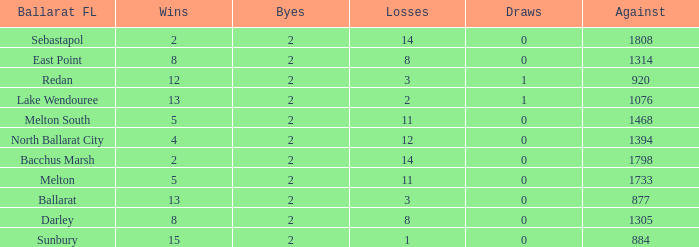Parse the table in full. {'header': ['Ballarat FL', 'Wins', 'Byes', 'Losses', 'Draws', 'Against'], 'rows': [['Sebastapol', '2', '2', '14', '0', '1808'], ['East Point', '8', '2', '8', '0', '1314'], ['Redan', '12', '2', '3', '1', '920'], ['Lake Wendouree', '13', '2', '2', '1', '1076'], ['Melton South', '5', '2', '11', '0', '1468'], ['North Ballarat City', '4', '2', '12', '0', '1394'], ['Bacchus Marsh', '2', '2', '14', '0', '1798'], ['Melton', '5', '2', '11', '0', '1733'], ['Ballarat', '13', '2', '3', '0', '877'], ['Darley', '8', '2', '8', '0', '1305'], ['Sunbury', '15', '2', '1', '0', '884']]} How many Against has Byes smaller than 2? None. 